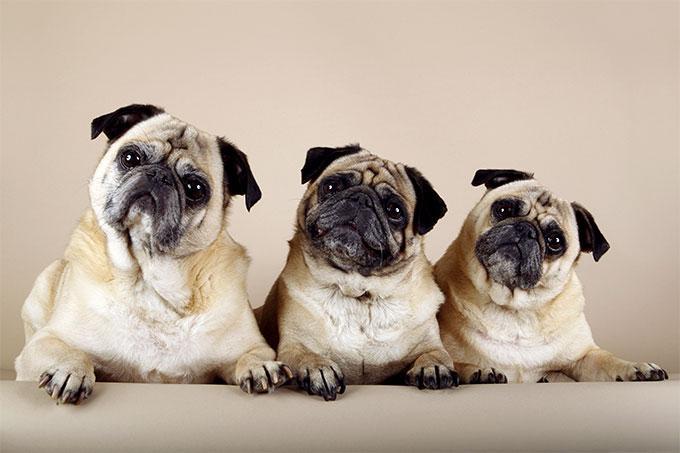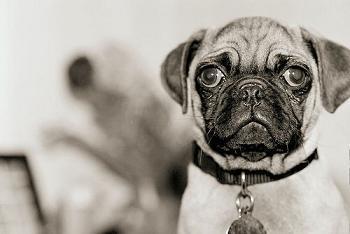The first image is the image on the left, the second image is the image on the right. Analyze the images presented: Is the assertion "There are three or fewer dogs in total." valid? Answer yes or no. No. The first image is the image on the left, the second image is the image on the right. Evaluate the accuracy of this statement regarding the images: "The right image contains at least two dogs.". Is it true? Answer yes or no. No. 